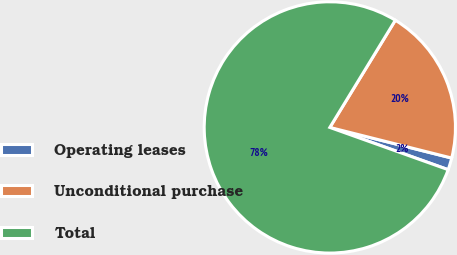Convert chart to OTSL. <chart><loc_0><loc_0><loc_500><loc_500><pie_chart><fcel>Operating leases<fcel>Unconditional purchase<fcel>Total<nl><fcel>1.54%<fcel>20.19%<fcel>78.27%<nl></chart> 